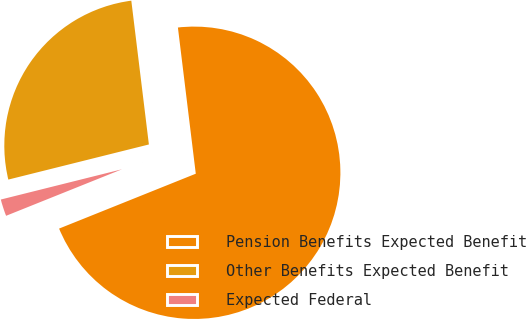Convert chart. <chart><loc_0><loc_0><loc_500><loc_500><pie_chart><fcel>Pension Benefits Expected Benefit<fcel>Other Benefits Expected Benefit<fcel>Expected Federal<nl><fcel>70.86%<fcel>26.96%<fcel>2.18%<nl></chart> 